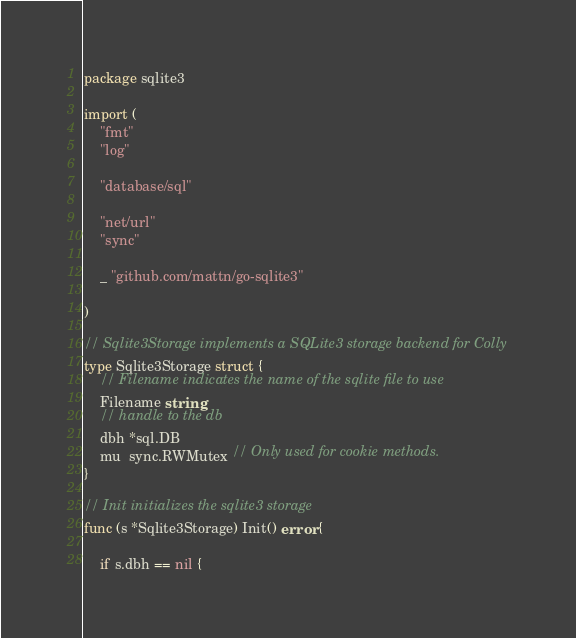Convert code to text. <code><loc_0><loc_0><loc_500><loc_500><_Go_>package sqlite3

import (
	"fmt"
	"log"

	"database/sql"

	"net/url"
	"sync"

	_ "github.com/mattn/go-sqlite3"

)

// Sqlite3Storage implements a SQLite3 storage backend for Colly
type Sqlite3Storage struct {
	// Filename indicates the name of the sqlite file to use
	Filename string
	// handle to the db
	dbh *sql.DB
	mu  sync.RWMutex // Only used for cookie methods.
}

// Init initializes the sqlite3 storage
func (s *Sqlite3Storage) Init() error {

	if s.dbh == nil {</code> 